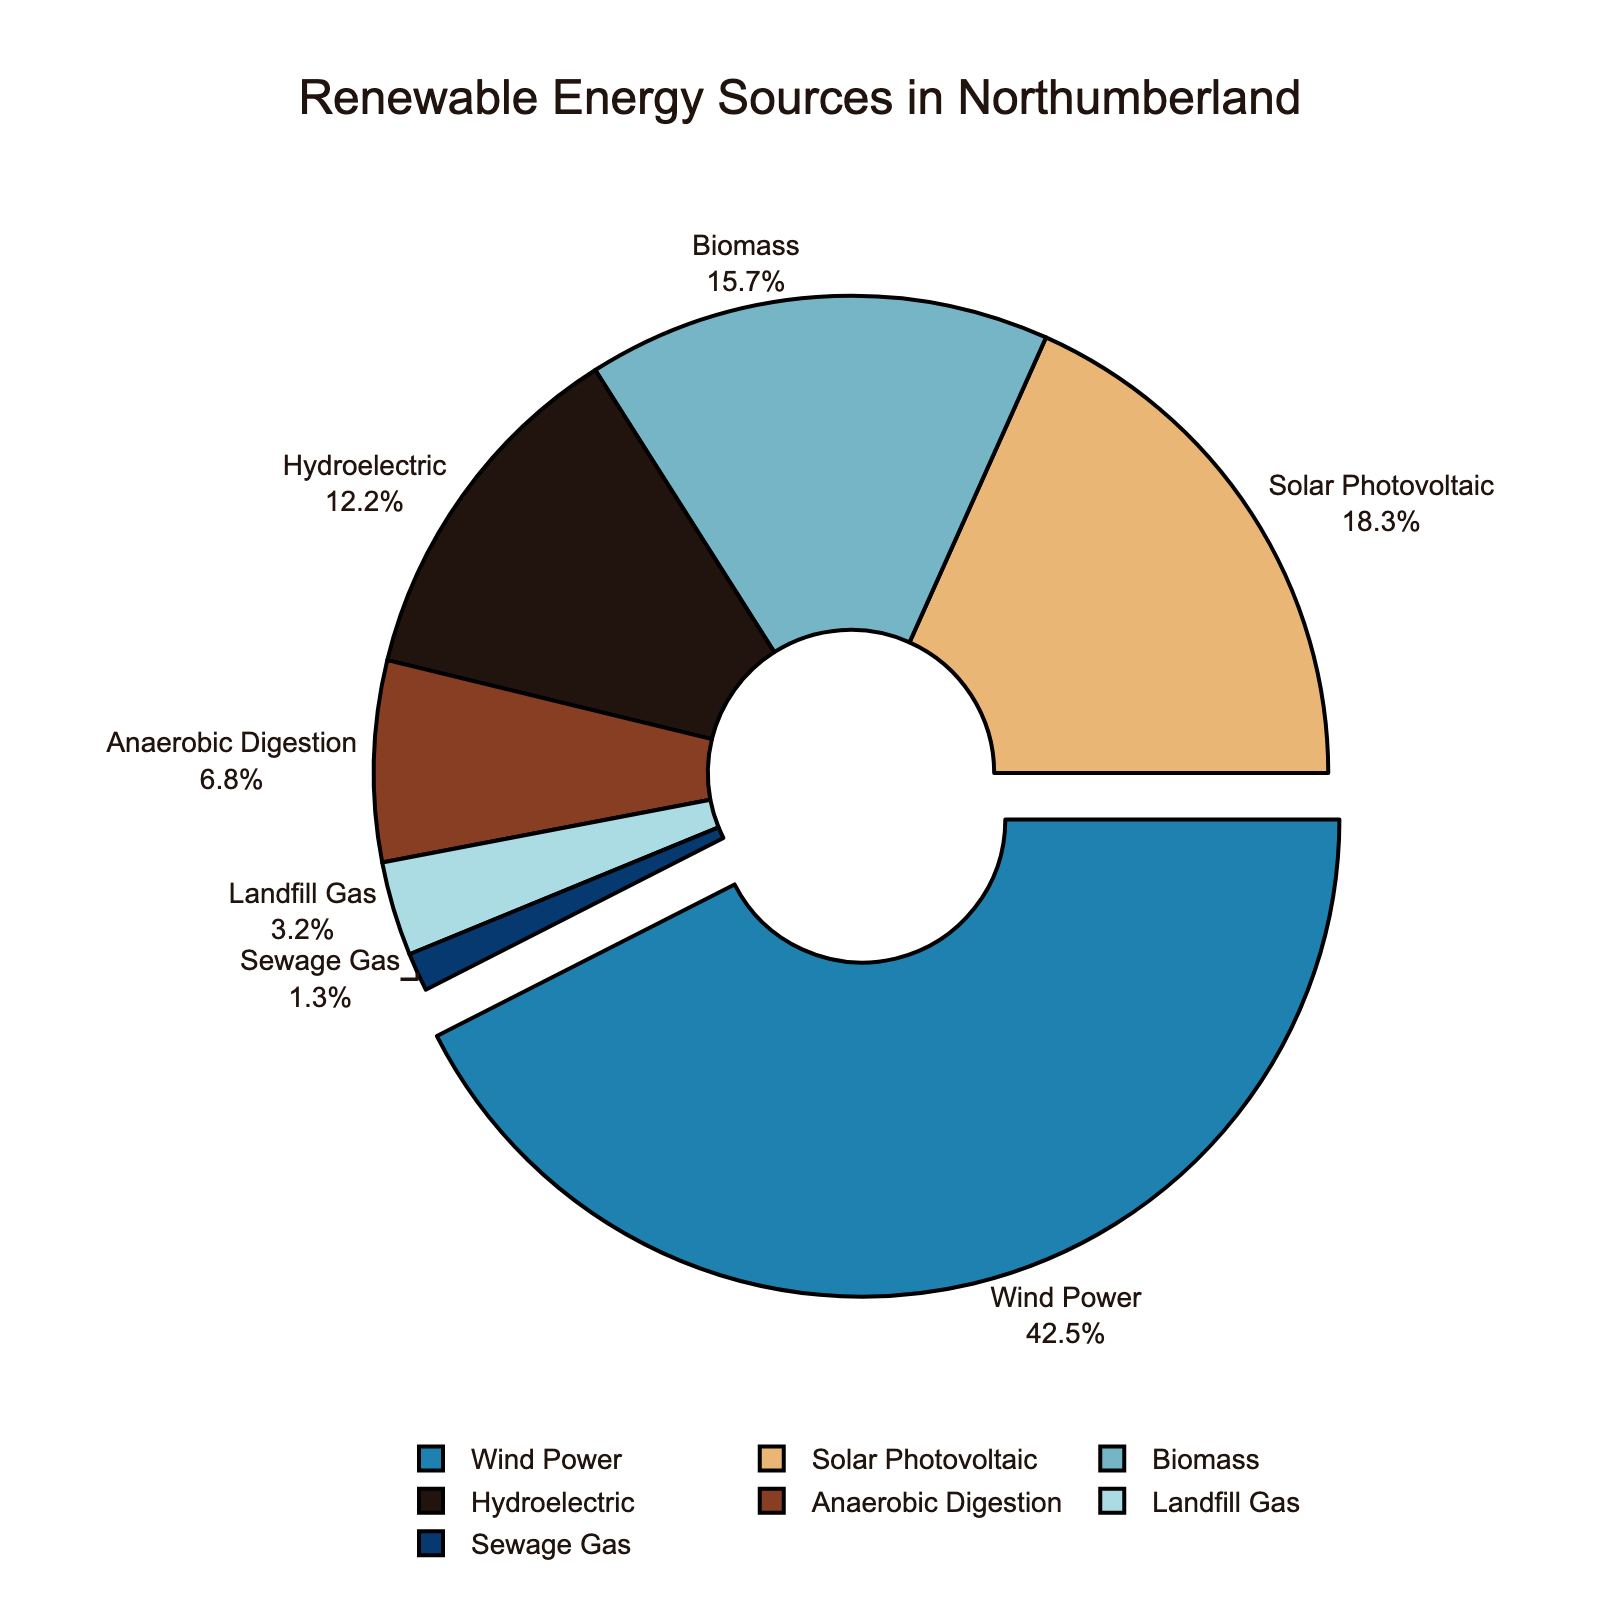Which renewable energy source has the highest contribution? The data shows the largest percentage contribution to wind power at 42.5%. The figure visually depicts this with a segment that is slightly pulled out and is the largest segment.
Answer: Wind Power What is the combined percentage contribution of Biomass and Hydroelectric? The percentages for Biomass and Hydroelectric are 15.7% and 12.2%, respectively. Summing them together gives 15.7 + 12.2 = 27.9%.
Answer: 27.9% Which renewable energy source has the least contribution? The data shows Sewage Gas with the smallest percentage at 1.3%. The figure visually depicts this with the smallest segment.
Answer: Sewage Gas Is the contribution of Solar Photovoltaic greater or less than Biomass? Solar Photovoltaic contributes 18.3%, whereas Biomass contributes 15.7%. Comparing these values, 18.3% is greater than 15.7%.
Answer: Greater How much more does Wind Power contribute compared to Anaerobic Digestion? Wind Power contributes 42.5%, and Anaerobic Digestion contributes 6.8%. The difference is 42.5 - 6.8 = 35.7%.
Answer: 35.7% What is the total contribution of energy sources other than Wind Power and Solar Photovoltaic? First, sum the percentages of Wind Power and Solar Photovoltaic: 42.5 + 18.3 = 60.8%. Then subtract this from 100%: 100 - 60.8 = 39.2%.
Answer: 39.2% Which two sources combined would almost equal the total contribution of Wind Power? Wind Power is 42.5%. Solar Photovoltaic combined with Biomass equals 18.3 + 15.7 = 34.0%, which is not very close. Solar Photovoltaic combined with Hydroelectric equals 18.3 + 12.2 = 30.5%, which is also not close. Biomass combined with Hydroelectric gives 15.7 + 12.2 = 27.9%, which is still not close. Anaerobic Digestion combined with any source falls short. Therefore, none of the combinations equal Wind Power's contribution exactly. However, Solar Photovoltaic and Biomass offer a close sum.
Answer: Solar Photovoltaic and Biomass Identify the color representing Landfill Gas in the figure. The figure uses a unique color for each energy source. Landfill Gas is represented by a distinct segment which is marked in a different color.
Answer: Light blue (labeled in the context provided as #abdbe3) 